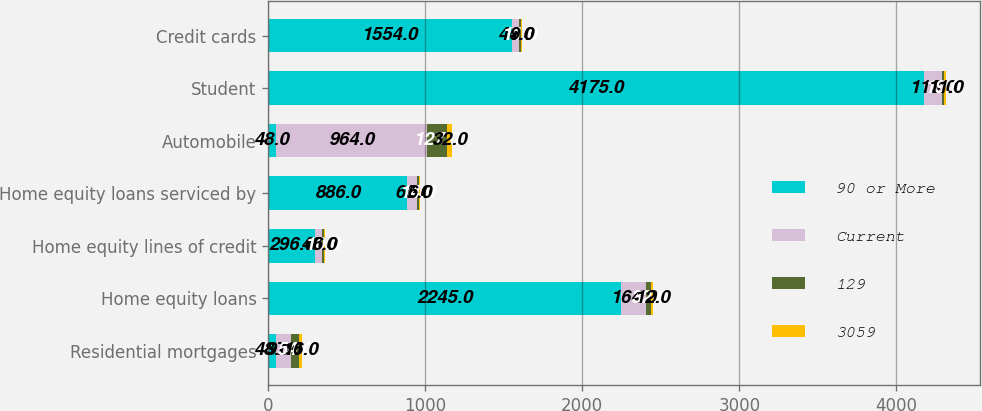Convert chart. <chart><loc_0><loc_0><loc_500><loc_500><stacked_bar_chart><ecel><fcel>Residential mortgages<fcel>Home equity loans<fcel>Home equity lines of credit<fcel>Home equity loans serviced by<fcel>Automobile<fcel>Student<fcel>Credit cards<nl><fcel>90 or More<fcel>48<fcel>2245<fcel>296<fcel>886<fcel>48<fcel>4175<fcel>1554<nl><fcel>Current<fcel>97<fcel>164<fcel>48<fcel>60<fcel>964<fcel>113<fcel>44<nl><fcel>129<fcel>54<fcel>32<fcel>10<fcel>14<fcel>127<fcel>19<fcel>11<nl><fcel>3059<fcel>16<fcel>12<fcel>6<fcel>6<fcel>32<fcel>11<fcel>9<nl></chart> 